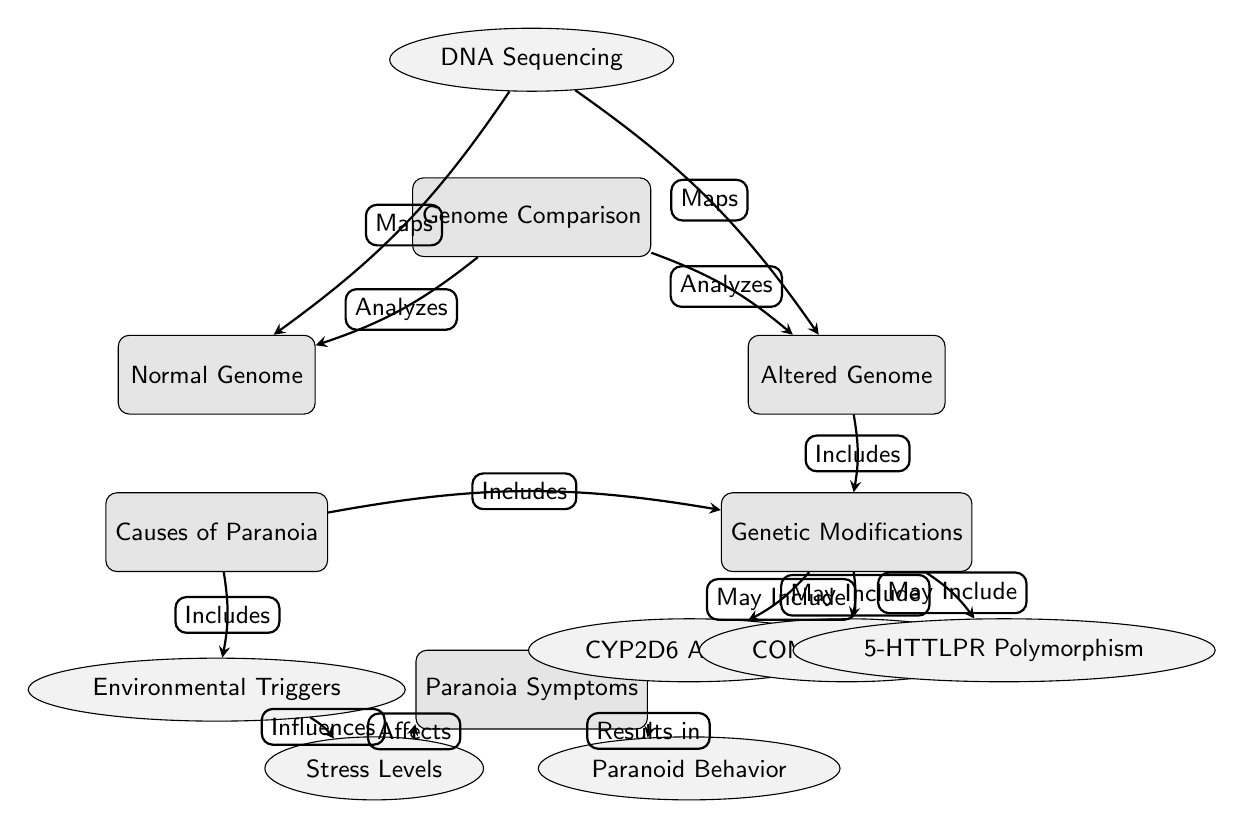What is the main subject of the diagram? The main subject is indicated in the central node labeled "Genome Comparison," which summarizes the overall focus of the diagram.
Answer: Genome Comparison How many sub-nodes are connected to the Altered Genome? The Altered Genome node has three sub-nodes connected to it: CYP2D6 Alteration, COMT Alteration, and 5-HTTLPR Polymorphism, counted directly from the edges leading from the Altered Genome node.
Answer: Three What influences Stress Levels according to the diagram? The diagram shows that Environmental Triggers influence Stress Levels, as indicated by the edge from the Environmental Triggers node pointing to the Stress Levels node.
Answer: Environmental Triggers What is the relationship between Genetic Modifications and Paranoia Symptoms? The Genetic Modifications node is linked directly to the Causes of Paranoia, which in turn leads to the Paranoia Symptoms node; thus, Genetic Modifications are part of the Causes of Paranoia contributing to the Paranoia Symptoms.
Answer: Causes of Paranoia Which node maps the Normal Genome? The DNA Sequencing node is responsible for mapping the Normal Genome, as shown by the directed edge leading from the DNA Sequencing node to the Normal Genome node.
Answer: DNA Sequencing How do Stress Levels affect Paranoia Symptoms? The edge connecting Stress Levels to Paranoia Symptoms indicates that Stress Levels affect Paranoia Symptoms, implying that variations in Stress Levels lead to variations in Paranoia Symptoms.
Answer: Affects What type of modification is included in the Altered Genome? The Altered Genome node includes Genetic Modifications, as shown by the direct connection from Altered Genome to Genetic Modifications indicating that this category encompasses alterations.
Answer: Genetic Modifications Which node summarizes the causes of paranoia? The node labeled "Causes of Paranoia" summarizes the factors that lead to paranoia, based on connections indicating contributing elements like Genetic Modifications and Environmental Triggers.
Answer: Causes of Paranoia What results in Paranoid Behavior? Paranoia Symptoms, as indicated in the diagram, result in Paranoid Behavior, shown by the directed edge from the Paranoia Symptoms node pointing to the Paranoid Behavior node.
Answer: Paranoia Symptoms 